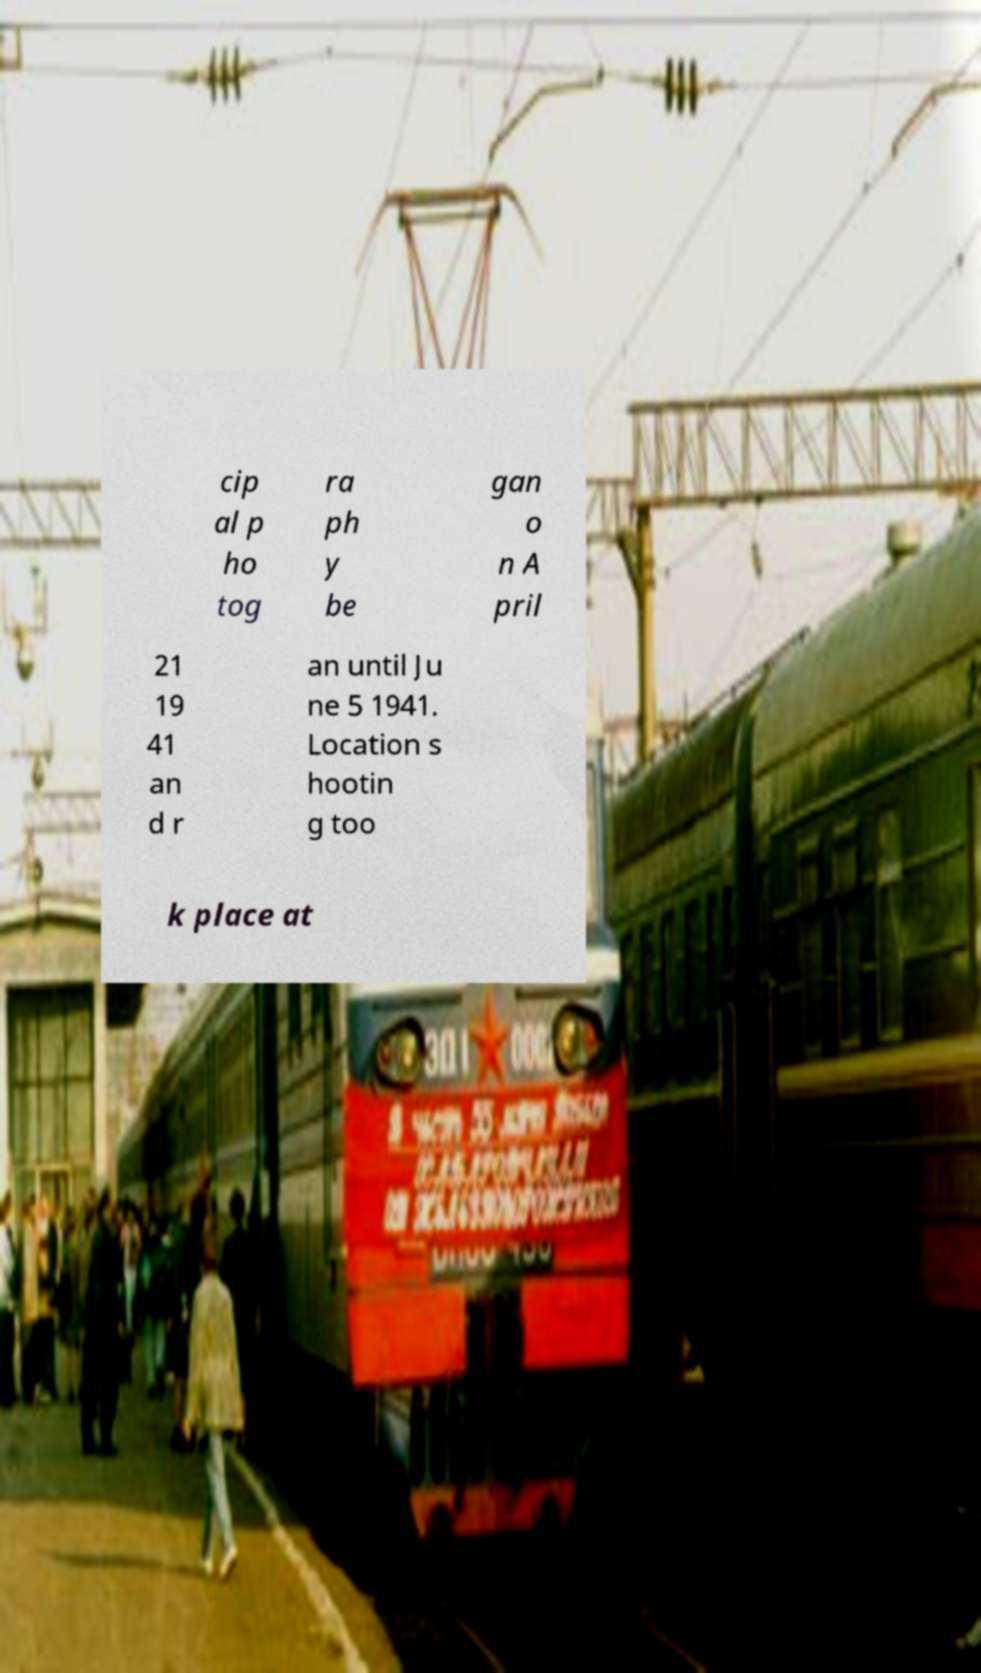What messages or text are displayed in this image? I need them in a readable, typed format. cip al p ho tog ra ph y be gan o n A pril 21 19 41 an d r an until Ju ne 5 1941. Location s hootin g too k place at 